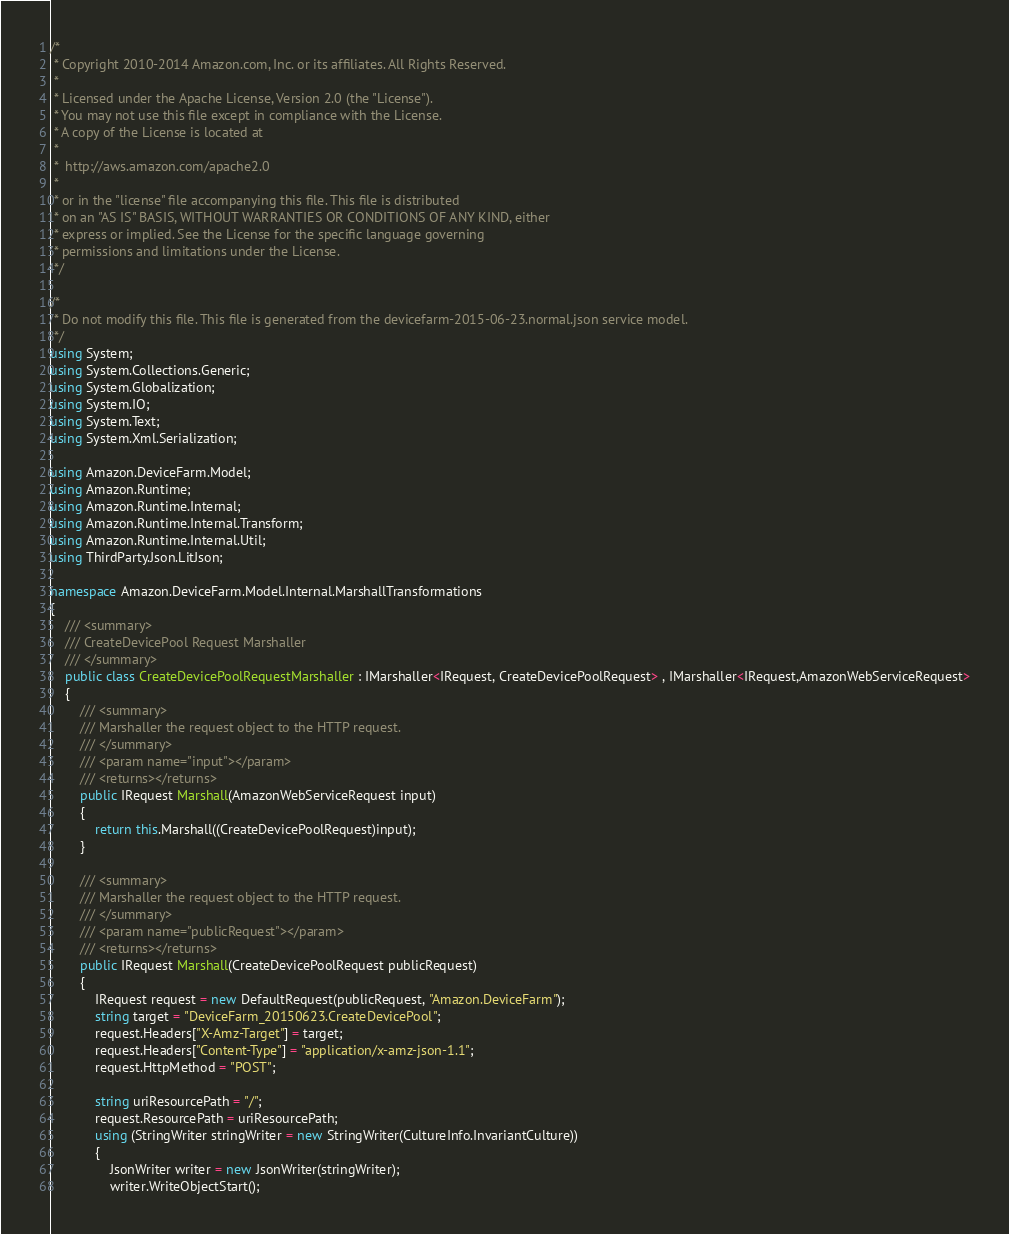Convert code to text. <code><loc_0><loc_0><loc_500><loc_500><_C#_>/*
 * Copyright 2010-2014 Amazon.com, Inc. or its affiliates. All Rights Reserved.
 * 
 * Licensed under the Apache License, Version 2.0 (the "License").
 * You may not use this file except in compliance with the License.
 * A copy of the License is located at
 * 
 *  http://aws.amazon.com/apache2.0
 * 
 * or in the "license" file accompanying this file. This file is distributed
 * on an "AS IS" BASIS, WITHOUT WARRANTIES OR CONDITIONS OF ANY KIND, either
 * express or implied. See the License for the specific language governing
 * permissions and limitations under the License.
 */

/*
 * Do not modify this file. This file is generated from the devicefarm-2015-06-23.normal.json service model.
 */
using System;
using System.Collections.Generic;
using System.Globalization;
using System.IO;
using System.Text;
using System.Xml.Serialization;

using Amazon.DeviceFarm.Model;
using Amazon.Runtime;
using Amazon.Runtime.Internal;
using Amazon.Runtime.Internal.Transform;
using Amazon.Runtime.Internal.Util;
using ThirdParty.Json.LitJson;

namespace Amazon.DeviceFarm.Model.Internal.MarshallTransformations
{
    /// <summary>
    /// CreateDevicePool Request Marshaller
    /// </summary>       
    public class CreateDevicePoolRequestMarshaller : IMarshaller<IRequest, CreateDevicePoolRequest> , IMarshaller<IRequest,AmazonWebServiceRequest>
    {
        /// <summary>
        /// Marshaller the request object to the HTTP request.
        /// </summary>  
        /// <param name="input"></param>
        /// <returns></returns>
        public IRequest Marshall(AmazonWebServiceRequest input)
        {
            return this.Marshall((CreateDevicePoolRequest)input);
        }

        /// <summary>
        /// Marshaller the request object to the HTTP request.
        /// </summary>  
        /// <param name="publicRequest"></param>
        /// <returns></returns>
        public IRequest Marshall(CreateDevicePoolRequest publicRequest)
        {
            IRequest request = new DefaultRequest(publicRequest, "Amazon.DeviceFarm");
            string target = "DeviceFarm_20150623.CreateDevicePool";
            request.Headers["X-Amz-Target"] = target;
            request.Headers["Content-Type"] = "application/x-amz-json-1.1";
            request.HttpMethod = "POST";

            string uriResourcePath = "/";
            request.ResourcePath = uriResourcePath;
            using (StringWriter stringWriter = new StringWriter(CultureInfo.InvariantCulture))
            {
                JsonWriter writer = new JsonWriter(stringWriter);
                writer.WriteObjectStart();</code> 